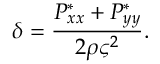<formula> <loc_0><loc_0><loc_500><loc_500>\delta = \frac { P _ { x x } ^ { * } + P _ { y y } ^ { * } } { 2 \rho \varsigma ^ { 2 } } .</formula> 